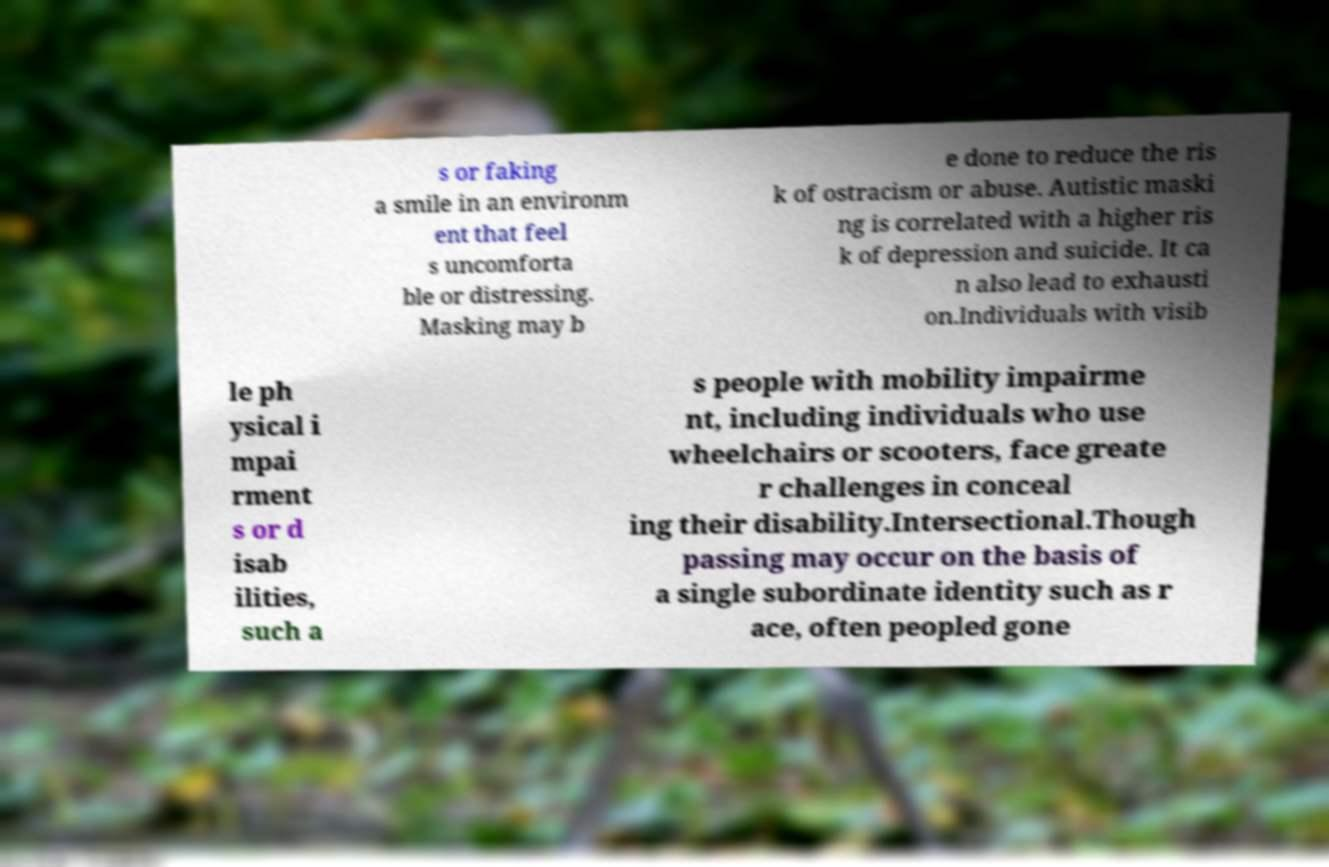For documentation purposes, I need the text within this image transcribed. Could you provide that? s or faking a smile in an environm ent that feel s uncomforta ble or distressing. Masking may b e done to reduce the ris k of ostracism or abuse. Autistic maski ng is correlated with a higher ris k of depression and suicide. It ca n also lead to exhausti on.Individuals with visib le ph ysical i mpai rment s or d isab ilities, such a s people with mobility impairme nt, including individuals who use wheelchairs or scooters, face greate r challenges in conceal ing their disability.Intersectional.Though passing may occur on the basis of a single subordinate identity such as r ace, often peopled gone 